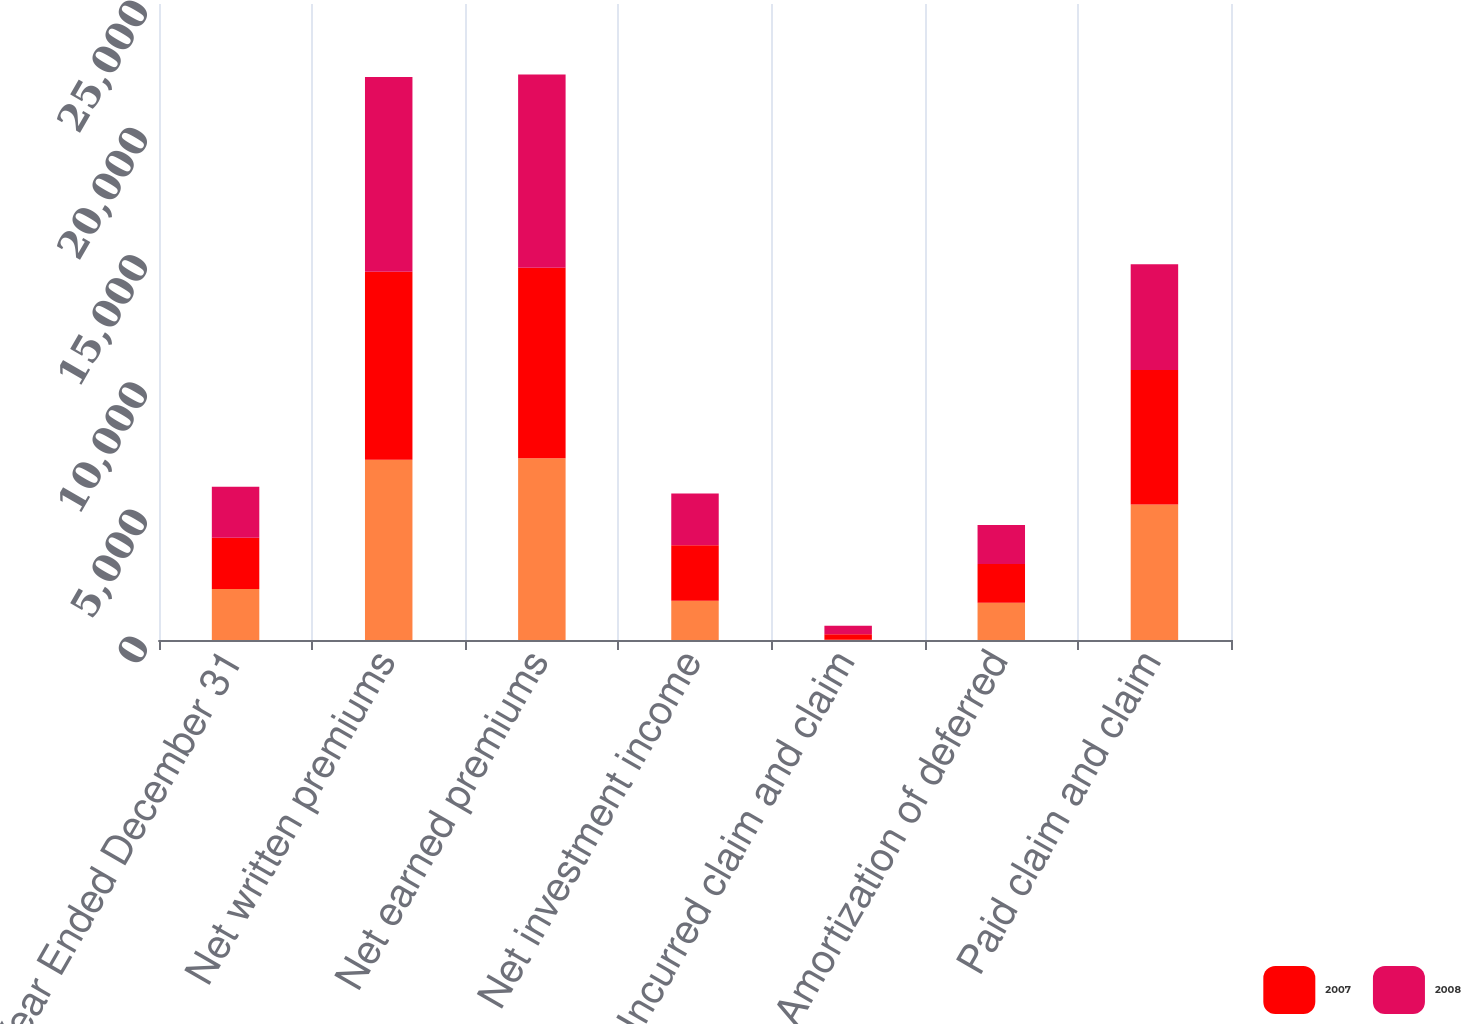Convert chart. <chart><loc_0><loc_0><loc_500><loc_500><stacked_bar_chart><ecel><fcel>Year Ended December 31<fcel>Net written premiums<fcel>Net earned premiums<fcel>Net investment income<fcel>Incurred claim and claim<fcel>Amortization of deferred<fcel>Paid claim and claim<nl><fcel>nan<fcel>2008<fcel>7090<fcel>7149<fcel>1547<fcel>7<fcel>1467<fcel>5327<nl><fcel>2007<fcel>2007<fcel>7382<fcel>7481<fcel>2180<fcel>220<fcel>1520<fcel>5282<nl><fcel>2008<fcel>2006<fcel>7655<fcel>7595<fcel>2035<fcel>332<fcel>1534<fcel>4165<nl></chart> 